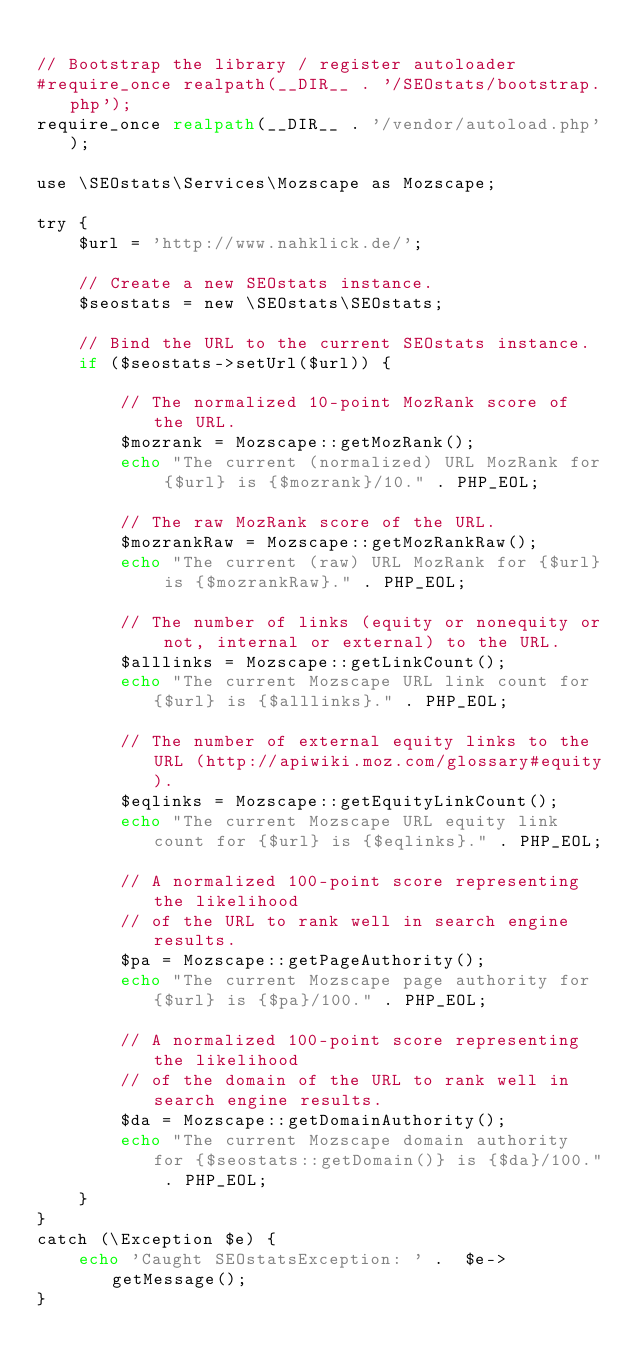<code> <loc_0><loc_0><loc_500><loc_500><_PHP_>
// Bootstrap the library / register autoloader
#require_once realpath(__DIR__ . '/SEOstats/bootstrap.php');
require_once realpath(__DIR__ . '/vendor/autoload.php');

use \SEOstats\Services\Mozscape as Mozscape;

try {
    $url = 'http://www.nahklick.de/';

    // Create a new SEOstats instance.
    $seostats = new \SEOstats\SEOstats;

    // Bind the URL to the current SEOstats instance.
    if ($seostats->setUrl($url)) {

        // The normalized 10-point MozRank score of the URL.
        $mozrank = Mozscape::getMozRank();
        echo "The current (normalized) URL MozRank for {$url} is {$mozrank}/10." . PHP_EOL;

        // The raw MozRank score of the URL.
        $mozrankRaw = Mozscape::getMozRankRaw();
        echo "The current (raw) URL MozRank for {$url} is {$mozrankRaw}." . PHP_EOL;

        // The number of links (equity or nonequity or not, internal or external) to the URL.
        $alllinks = Mozscape::getLinkCount();
        echo "The current Mozscape URL link count for {$url} is {$alllinks}." . PHP_EOL;

        // The number of external equity links to the URL (http://apiwiki.moz.com/glossary#equity).
        $eqlinks = Mozscape::getEquityLinkCount();
        echo "The current Mozscape URL equity link count for {$url} is {$eqlinks}." . PHP_EOL;

        // A normalized 100-point score representing the likelihood
        // of the URL to rank well in search engine results.
        $pa = Mozscape::getPageAuthority();
        echo "The current Mozscape page authority for {$url} is {$pa}/100." . PHP_EOL;

        // A normalized 100-point score representing the likelihood
        // of the domain of the URL to rank well in search engine results.
        $da = Mozscape::getDomainAuthority();
        echo "The current Mozscape domain authority for {$seostats::getDomain()} is {$da}/100." . PHP_EOL;
    }
}
catch (\Exception $e) {
    echo 'Caught SEOstatsException: ' .  $e->getMessage();
}
</code> 